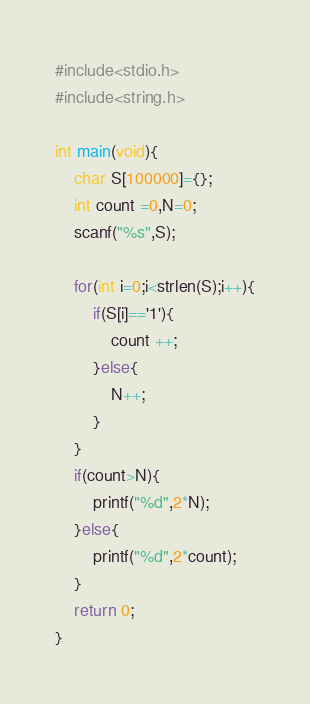<code> <loc_0><loc_0><loc_500><loc_500><_C_>#include<stdio.h>
#include<string.h>

int main(void){
    char S[100000]={};
    int count =0,N=0;
    scanf("%s",S);
    
    for(int i=0;i<strlen(S);i++){
        if(S[i]=='1'){
            count ++;
        }else{
            N++;
        }
    }
    if(count>N){
        printf("%d",2*N);
    }else{
        printf("%d",2*count);
    }
    return 0;
}</code> 